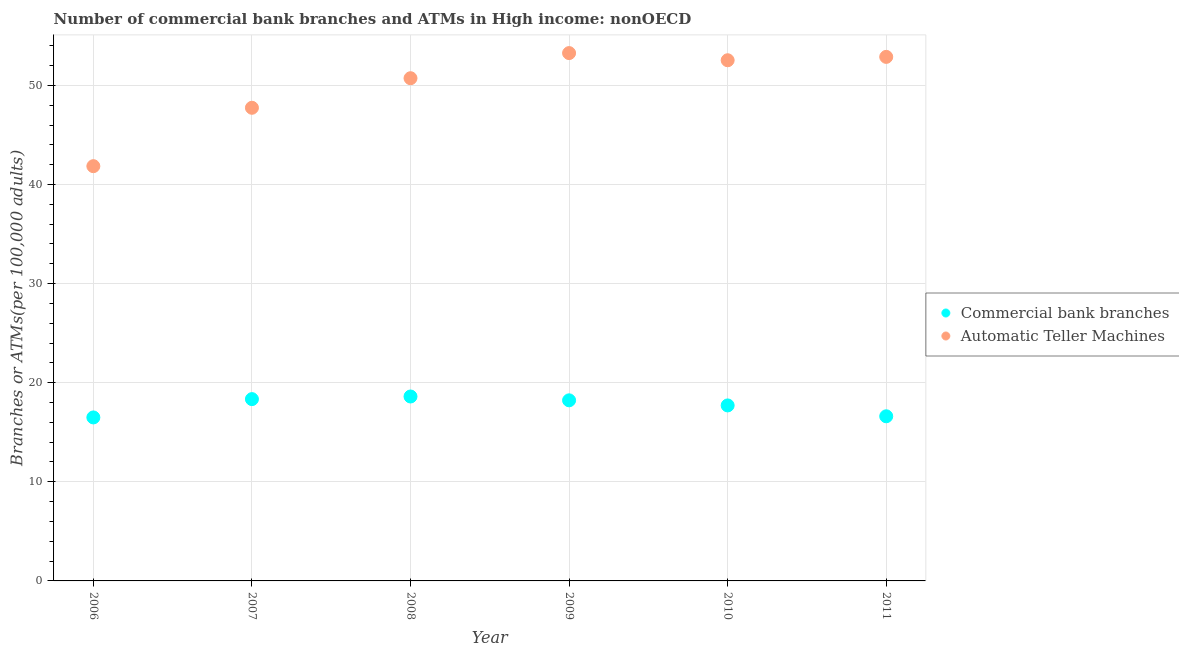What is the number of commercal bank branches in 2006?
Make the answer very short. 16.5. Across all years, what is the maximum number of atms?
Your response must be concise. 53.26. Across all years, what is the minimum number of atms?
Make the answer very short. 41.85. In which year was the number of atms maximum?
Offer a very short reply. 2009. In which year was the number of atms minimum?
Your answer should be very brief. 2006. What is the total number of atms in the graph?
Keep it short and to the point. 298.98. What is the difference between the number of commercal bank branches in 2007 and that in 2008?
Keep it short and to the point. -0.26. What is the difference between the number of atms in 2007 and the number of commercal bank branches in 2010?
Offer a very short reply. 30.03. What is the average number of commercal bank branches per year?
Make the answer very short. 17.66. In the year 2008, what is the difference between the number of commercal bank branches and number of atms?
Offer a terse response. -32.11. What is the ratio of the number of atms in 2007 to that in 2009?
Your response must be concise. 0.9. What is the difference between the highest and the second highest number of commercal bank branches?
Make the answer very short. 0.26. What is the difference between the highest and the lowest number of commercal bank branches?
Provide a succinct answer. 2.11. Is the sum of the number of atms in 2007 and 2011 greater than the maximum number of commercal bank branches across all years?
Give a very brief answer. Yes. Is the number of commercal bank branches strictly less than the number of atms over the years?
Ensure brevity in your answer.  Yes. Are the values on the major ticks of Y-axis written in scientific E-notation?
Keep it short and to the point. No. How many legend labels are there?
Give a very brief answer. 2. What is the title of the graph?
Offer a terse response. Number of commercial bank branches and ATMs in High income: nonOECD. What is the label or title of the Y-axis?
Your answer should be compact. Branches or ATMs(per 100,0 adults). What is the Branches or ATMs(per 100,000 adults) of Commercial bank branches in 2006?
Ensure brevity in your answer.  16.5. What is the Branches or ATMs(per 100,000 adults) of Automatic Teller Machines in 2006?
Your answer should be compact. 41.85. What is the Branches or ATMs(per 100,000 adults) in Commercial bank branches in 2007?
Offer a very short reply. 18.34. What is the Branches or ATMs(per 100,000 adults) of Automatic Teller Machines in 2007?
Offer a terse response. 47.74. What is the Branches or ATMs(per 100,000 adults) in Commercial bank branches in 2008?
Provide a succinct answer. 18.61. What is the Branches or ATMs(per 100,000 adults) in Automatic Teller Machines in 2008?
Provide a short and direct response. 50.72. What is the Branches or ATMs(per 100,000 adults) of Commercial bank branches in 2009?
Make the answer very short. 18.22. What is the Branches or ATMs(per 100,000 adults) in Automatic Teller Machines in 2009?
Provide a succinct answer. 53.26. What is the Branches or ATMs(per 100,000 adults) of Commercial bank branches in 2010?
Your answer should be compact. 17.71. What is the Branches or ATMs(per 100,000 adults) of Automatic Teller Machines in 2010?
Offer a very short reply. 52.53. What is the Branches or ATMs(per 100,000 adults) of Commercial bank branches in 2011?
Your response must be concise. 16.61. What is the Branches or ATMs(per 100,000 adults) of Automatic Teller Machines in 2011?
Make the answer very short. 52.87. Across all years, what is the maximum Branches or ATMs(per 100,000 adults) in Commercial bank branches?
Offer a very short reply. 18.61. Across all years, what is the maximum Branches or ATMs(per 100,000 adults) of Automatic Teller Machines?
Your response must be concise. 53.26. Across all years, what is the minimum Branches or ATMs(per 100,000 adults) in Commercial bank branches?
Your answer should be very brief. 16.5. Across all years, what is the minimum Branches or ATMs(per 100,000 adults) of Automatic Teller Machines?
Give a very brief answer. 41.85. What is the total Branches or ATMs(per 100,000 adults) of Commercial bank branches in the graph?
Offer a very short reply. 105.99. What is the total Branches or ATMs(per 100,000 adults) of Automatic Teller Machines in the graph?
Your response must be concise. 298.98. What is the difference between the Branches or ATMs(per 100,000 adults) in Commercial bank branches in 2006 and that in 2007?
Your answer should be very brief. -1.85. What is the difference between the Branches or ATMs(per 100,000 adults) in Automatic Teller Machines in 2006 and that in 2007?
Provide a short and direct response. -5.89. What is the difference between the Branches or ATMs(per 100,000 adults) in Commercial bank branches in 2006 and that in 2008?
Your response must be concise. -2.11. What is the difference between the Branches or ATMs(per 100,000 adults) of Automatic Teller Machines in 2006 and that in 2008?
Your answer should be compact. -8.87. What is the difference between the Branches or ATMs(per 100,000 adults) in Commercial bank branches in 2006 and that in 2009?
Offer a terse response. -1.73. What is the difference between the Branches or ATMs(per 100,000 adults) of Automatic Teller Machines in 2006 and that in 2009?
Offer a terse response. -11.41. What is the difference between the Branches or ATMs(per 100,000 adults) of Commercial bank branches in 2006 and that in 2010?
Your answer should be very brief. -1.21. What is the difference between the Branches or ATMs(per 100,000 adults) in Automatic Teller Machines in 2006 and that in 2010?
Keep it short and to the point. -10.69. What is the difference between the Branches or ATMs(per 100,000 adults) of Commercial bank branches in 2006 and that in 2011?
Make the answer very short. -0.12. What is the difference between the Branches or ATMs(per 100,000 adults) of Automatic Teller Machines in 2006 and that in 2011?
Make the answer very short. -11.03. What is the difference between the Branches or ATMs(per 100,000 adults) of Commercial bank branches in 2007 and that in 2008?
Keep it short and to the point. -0.26. What is the difference between the Branches or ATMs(per 100,000 adults) of Automatic Teller Machines in 2007 and that in 2008?
Your answer should be very brief. -2.98. What is the difference between the Branches or ATMs(per 100,000 adults) in Commercial bank branches in 2007 and that in 2009?
Ensure brevity in your answer.  0.12. What is the difference between the Branches or ATMs(per 100,000 adults) of Automatic Teller Machines in 2007 and that in 2009?
Offer a terse response. -5.52. What is the difference between the Branches or ATMs(per 100,000 adults) of Commercial bank branches in 2007 and that in 2010?
Your answer should be compact. 0.64. What is the difference between the Branches or ATMs(per 100,000 adults) in Automatic Teller Machines in 2007 and that in 2010?
Ensure brevity in your answer.  -4.8. What is the difference between the Branches or ATMs(per 100,000 adults) in Commercial bank branches in 2007 and that in 2011?
Ensure brevity in your answer.  1.73. What is the difference between the Branches or ATMs(per 100,000 adults) of Automatic Teller Machines in 2007 and that in 2011?
Offer a very short reply. -5.14. What is the difference between the Branches or ATMs(per 100,000 adults) in Commercial bank branches in 2008 and that in 2009?
Make the answer very short. 0.39. What is the difference between the Branches or ATMs(per 100,000 adults) of Automatic Teller Machines in 2008 and that in 2009?
Give a very brief answer. -2.53. What is the difference between the Branches or ATMs(per 100,000 adults) in Commercial bank branches in 2008 and that in 2010?
Provide a short and direct response. 0.9. What is the difference between the Branches or ATMs(per 100,000 adults) in Automatic Teller Machines in 2008 and that in 2010?
Provide a short and direct response. -1.81. What is the difference between the Branches or ATMs(per 100,000 adults) in Commercial bank branches in 2008 and that in 2011?
Offer a terse response. 2. What is the difference between the Branches or ATMs(per 100,000 adults) of Automatic Teller Machines in 2008 and that in 2011?
Your answer should be compact. -2.15. What is the difference between the Branches or ATMs(per 100,000 adults) of Commercial bank branches in 2009 and that in 2010?
Keep it short and to the point. 0.51. What is the difference between the Branches or ATMs(per 100,000 adults) of Automatic Teller Machines in 2009 and that in 2010?
Offer a very short reply. 0.72. What is the difference between the Branches or ATMs(per 100,000 adults) of Commercial bank branches in 2009 and that in 2011?
Keep it short and to the point. 1.61. What is the difference between the Branches or ATMs(per 100,000 adults) of Automatic Teller Machines in 2009 and that in 2011?
Keep it short and to the point. 0.38. What is the difference between the Branches or ATMs(per 100,000 adults) of Commercial bank branches in 2010 and that in 2011?
Provide a short and direct response. 1.1. What is the difference between the Branches or ATMs(per 100,000 adults) of Automatic Teller Machines in 2010 and that in 2011?
Keep it short and to the point. -0.34. What is the difference between the Branches or ATMs(per 100,000 adults) in Commercial bank branches in 2006 and the Branches or ATMs(per 100,000 adults) in Automatic Teller Machines in 2007?
Offer a terse response. -31.24. What is the difference between the Branches or ATMs(per 100,000 adults) in Commercial bank branches in 2006 and the Branches or ATMs(per 100,000 adults) in Automatic Teller Machines in 2008?
Offer a terse response. -34.23. What is the difference between the Branches or ATMs(per 100,000 adults) in Commercial bank branches in 2006 and the Branches or ATMs(per 100,000 adults) in Automatic Teller Machines in 2009?
Keep it short and to the point. -36.76. What is the difference between the Branches or ATMs(per 100,000 adults) of Commercial bank branches in 2006 and the Branches or ATMs(per 100,000 adults) of Automatic Teller Machines in 2010?
Offer a very short reply. -36.04. What is the difference between the Branches or ATMs(per 100,000 adults) of Commercial bank branches in 2006 and the Branches or ATMs(per 100,000 adults) of Automatic Teller Machines in 2011?
Offer a terse response. -36.38. What is the difference between the Branches or ATMs(per 100,000 adults) in Commercial bank branches in 2007 and the Branches or ATMs(per 100,000 adults) in Automatic Teller Machines in 2008?
Offer a terse response. -32.38. What is the difference between the Branches or ATMs(per 100,000 adults) in Commercial bank branches in 2007 and the Branches or ATMs(per 100,000 adults) in Automatic Teller Machines in 2009?
Offer a very short reply. -34.91. What is the difference between the Branches or ATMs(per 100,000 adults) in Commercial bank branches in 2007 and the Branches or ATMs(per 100,000 adults) in Automatic Teller Machines in 2010?
Make the answer very short. -34.19. What is the difference between the Branches or ATMs(per 100,000 adults) in Commercial bank branches in 2007 and the Branches or ATMs(per 100,000 adults) in Automatic Teller Machines in 2011?
Your answer should be very brief. -34.53. What is the difference between the Branches or ATMs(per 100,000 adults) of Commercial bank branches in 2008 and the Branches or ATMs(per 100,000 adults) of Automatic Teller Machines in 2009?
Keep it short and to the point. -34.65. What is the difference between the Branches or ATMs(per 100,000 adults) in Commercial bank branches in 2008 and the Branches or ATMs(per 100,000 adults) in Automatic Teller Machines in 2010?
Provide a short and direct response. -33.93. What is the difference between the Branches or ATMs(per 100,000 adults) of Commercial bank branches in 2008 and the Branches or ATMs(per 100,000 adults) of Automatic Teller Machines in 2011?
Make the answer very short. -34.27. What is the difference between the Branches or ATMs(per 100,000 adults) in Commercial bank branches in 2009 and the Branches or ATMs(per 100,000 adults) in Automatic Teller Machines in 2010?
Provide a succinct answer. -34.31. What is the difference between the Branches or ATMs(per 100,000 adults) of Commercial bank branches in 2009 and the Branches or ATMs(per 100,000 adults) of Automatic Teller Machines in 2011?
Offer a very short reply. -34.65. What is the difference between the Branches or ATMs(per 100,000 adults) in Commercial bank branches in 2010 and the Branches or ATMs(per 100,000 adults) in Automatic Teller Machines in 2011?
Keep it short and to the point. -35.17. What is the average Branches or ATMs(per 100,000 adults) of Commercial bank branches per year?
Give a very brief answer. 17.66. What is the average Branches or ATMs(per 100,000 adults) in Automatic Teller Machines per year?
Offer a terse response. 49.83. In the year 2006, what is the difference between the Branches or ATMs(per 100,000 adults) in Commercial bank branches and Branches or ATMs(per 100,000 adults) in Automatic Teller Machines?
Your answer should be compact. -25.35. In the year 2007, what is the difference between the Branches or ATMs(per 100,000 adults) of Commercial bank branches and Branches or ATMs(per 100,000 adults) of Automatic Teller Machines?
Keep it short and to the point. -29.4. In the year 2008, what is the difference between the Branches or ATMs(per 100,000 adults) in Commercial bank branches and Branches or ATMs(per 100,000 adults) in Automatic Teller Machines?
Offer a very short reply. -32.11. In the year 2009, what is the difference between the Branches or ATMs(per 100,000 adults) in Commercial bank branches and Branches or ATMs(per 100,000 adults) in Automatic Teller Machines?
Keep it short and to the point. -35.04. In the year 2010, what is the difference between the Branches or ATMs(per 100,000 adults) of Commercial bank branches and Branches or ATMs(per 100,000 adults) of Automatic Teller Machines?
Make the answer very short. -34.83. In the year 2011, what is the difference between the Branches or ATMs(per 100,000 adults) in Commercial bank branches and Branches or ATMs(per 100,000 adults) in Automatic Teller Machines?
Your answer should be compact. -36.26. What is the ratio of the Branches or ATMs(per 100,000 adults) of Commercial bank branches in 2006 to that in 2007?
Your response must be concise. 0.9. What is the ratio of the Branches or ATMs(per 100,000 adults) in Automatic Teller Machines in 2006 to that in 2007?
Offer a terse response. 0.88. What is the ratio of the Branches or ATMs(per 100,000 adults) of Commercial bank branches in 2006 to that in 2008?
Give a very brief answer. 0.89. What is the ratio of the Branches or ATMs(per 100,000 adults) in Automatic Teller Machines in 2006 to that in 2008?
Your response must be concise. 0.83. What is the ratio of the Branches or ATMs(per 100,000 adults) in Commercial bank branches in 2006 to that in 2009?
Provide a succinct answer. 0.91. What is the ratio of the Branches or ATMs(per 100,000 adults) of Automatic Teller Machines in 2006 to that in 2009?
Make the answer very short. 0.79. What is the ratio of the Branches or ATMs(per 100,000 adults) of Commercial bank branches in 2006 to that in 2010?
Offer a terse response. 0.93. What is the ratio of the Branches or ATMs(per 100,000 adults) in Automatic Teller Machines in 2006 to that in 2010?
Keep it short and to the point. 0.8. What is the ratio of the Branches or ATMs(per 100,000 adults) of Commercial bank branches in 2006 to that in 2011?
Ensure brevity in your answer.  0.99. What is the ratio of the Branches or ATMs(per 100,000 adults) of Automatic Teller Machines in 2006 to that in 2011?
Your answer should be compact. 0.79. What is the ratio of the Branches or ATMs(per 100,000 adults) in Commercial bank branches in 2007 to that in 2008?
Ensure brevity in your answer.  0.99. What is the ratio of the Branches or ATMs(per 100,000 adults) in Automatic Teller Machines in 2007 to that in 2009?
Your answer should be compact. 0.9. What is the ratio of the Branches or ATMs(per 100,000 adults) of Commercial bank branches in 2007 to that in 2010?
Provide a succinct answer. 1.04. What is the ratio of the Branches or ATMs(per 100,000 adults) of Automatic Teller Machines in 2007 to that in 2010?
Ensure brevity in your answer.  0.91. What is the ratio of the Branches or ATMs(per 100,000 adults) of Commercial bank branches in 2007 to that in 2011?
Give a very brief answer. 1.1. What is the ratio of the Branches or ATMs(per 100,000 adults) in Automatic Teller Machines in 2007 to that in 2011?
Provide a short and direct response. 0.9. What is the ratio of the Branches or ATMs(per 100,000 adults) of Commercial bank branches in 2008 to that in 2009?
Your answer should be compact. 1.02. What is the ratio of the Branches or ATMs(per 100,000 adults) in Automatic Teller Machines in 2008 to that in 2009?
Provide a short and direct response. 0.95. What is the ratio of the Branches or ATMs(per 100,000 adults) in Commercial bank branches in 2008 to that in 2010?
Provide a short and direct response. 1.05. What is the ratio of the Branches or ATMs(per 100,000 adults) in Automatic Teller Machines in 2008 to that in 2010?
Provide a short and direct response. 0.97. What is the ratio of the Branches or ATMs(per 100,000 adults) in Commercial bank branches in 2008 to that in 2011?
Provide a short and direct response. 1.12. What is the ratio of the Branches or ATMs(per 100,000 adults) of Automatic Teller Machines in 2008 to that in 2011?
Provide a succinct answer. 0.96. What is the ratio of the Branches or ATMs(per 100,000 adults) in Commercial bank branches in 2009 to that in 2010?
Your response must be concise. 1.03. What is the ratio of the Branches or ATMs(per 100,000 adults) of Automatic Teller Machines in 2009 to that in 2010?
Make the answer very short. 1.01. What is the ratio of the Branches or ATMs(per 100,000 adults) in Commercial bank branches in 2009 to that in 2011?
Offer a terse response. 1.1. What is the ratio of the Branches or ATMs(per 100,000 adults) in Automatic Teller Machines in 2009 to that in 2011?
Your answer should be very brief. 1.01. What is the ratio of the Branches or ATMs(per 100,000 adults) of Commercial bank branches in 2010 to that in 2011?
Offer a terse response. 1.07. What is the ratio of the Branches or ATMs(per 100,000 adults) of Automatic Teller Machines in 2010 to that in 2011?
Provide a succinct answer. 0.99. What is the difference between the highest and the second highest Branches or ATMs(per 100,000 adults) of Commercial bank branches?
Provide a succinct answer. 0.26. What is the difference between the highest and the second highest Branches or ATMs(per 100,000 adults) of Automatic Teller Machines?
Your answer should be compact. 0.38. What is the difference between the highest and the lowest Branches or ATMs(per 100,000 adults) of Commercial bank branches?
Offer a very short reply. 2.11. What is the difference between the highest and the lowest Branches or ATMs(per 100,000 adults) in Automatic Teller Machines?
Keep it short and to the point. 11.41. 